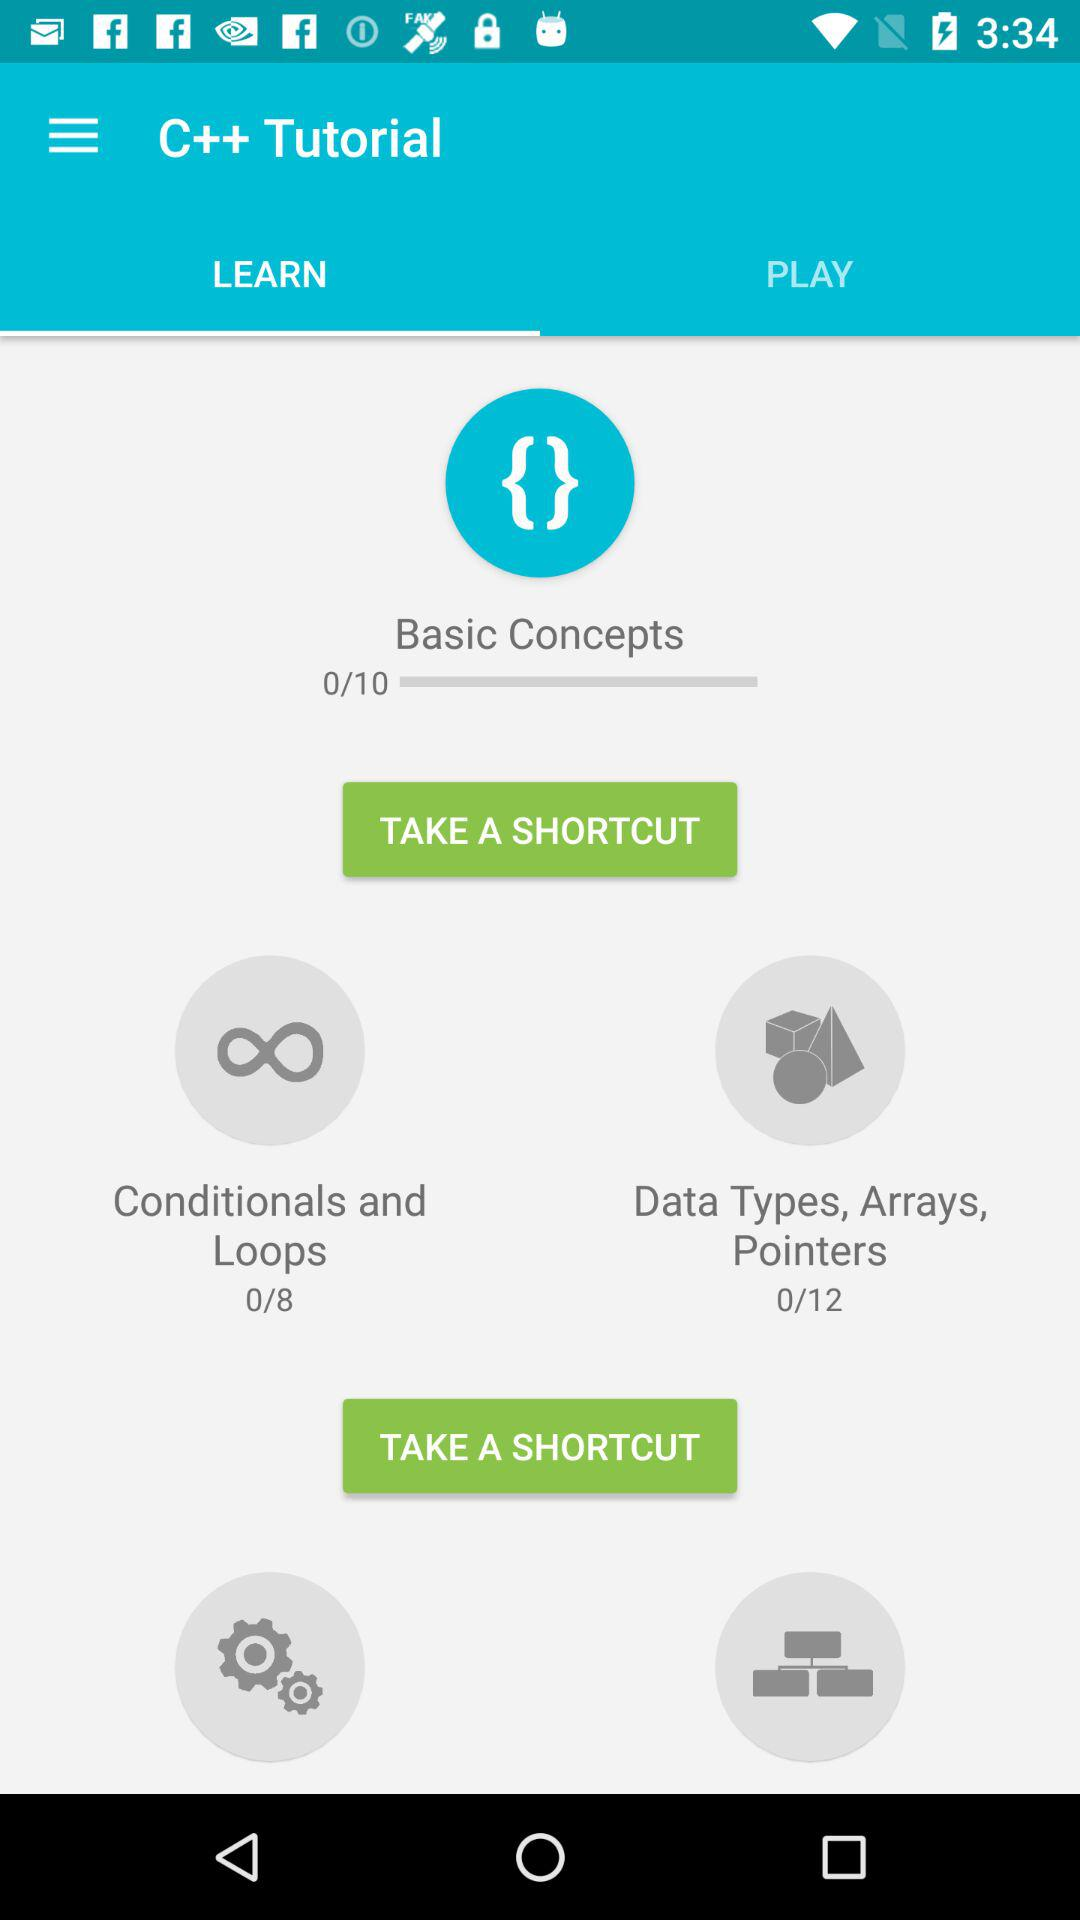Which tab is selected? The selected tab is "LEARN". 